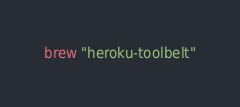Convert code to text. <code><loc_0><loc_0><loc_500><loc_500><_Ruby_>
brew "heroku-toolbelt"
</code> 